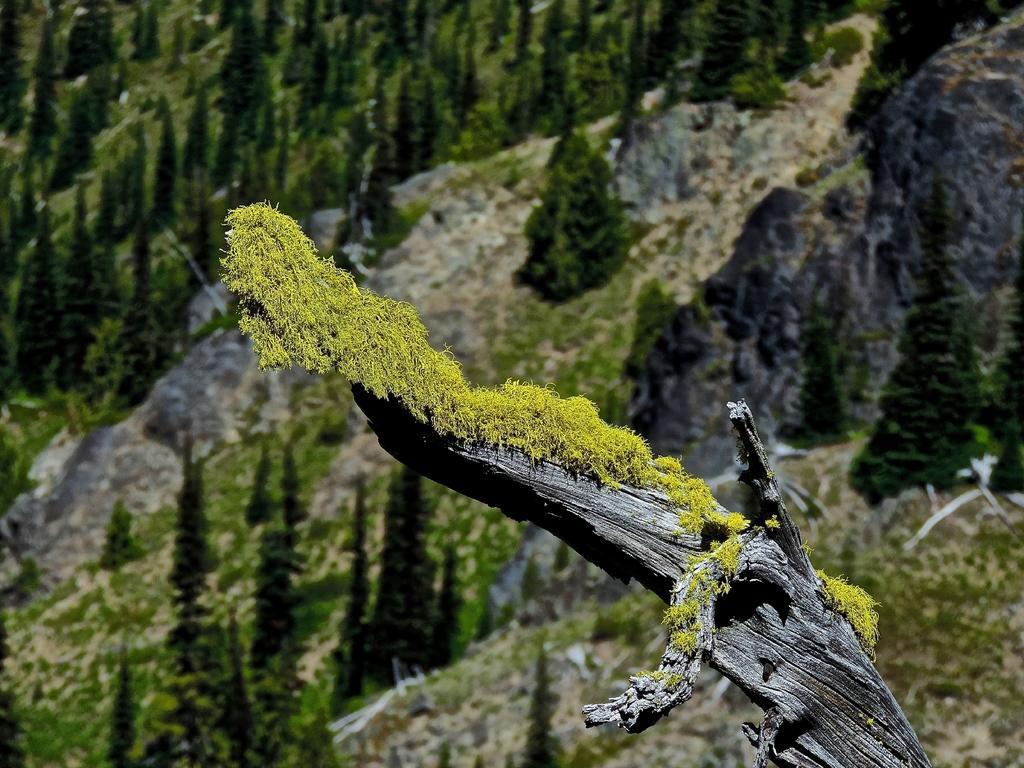Can you describe this image briefly? This is the picture of a tree trunk on which there is a mosses and around there are some trees and plants. 